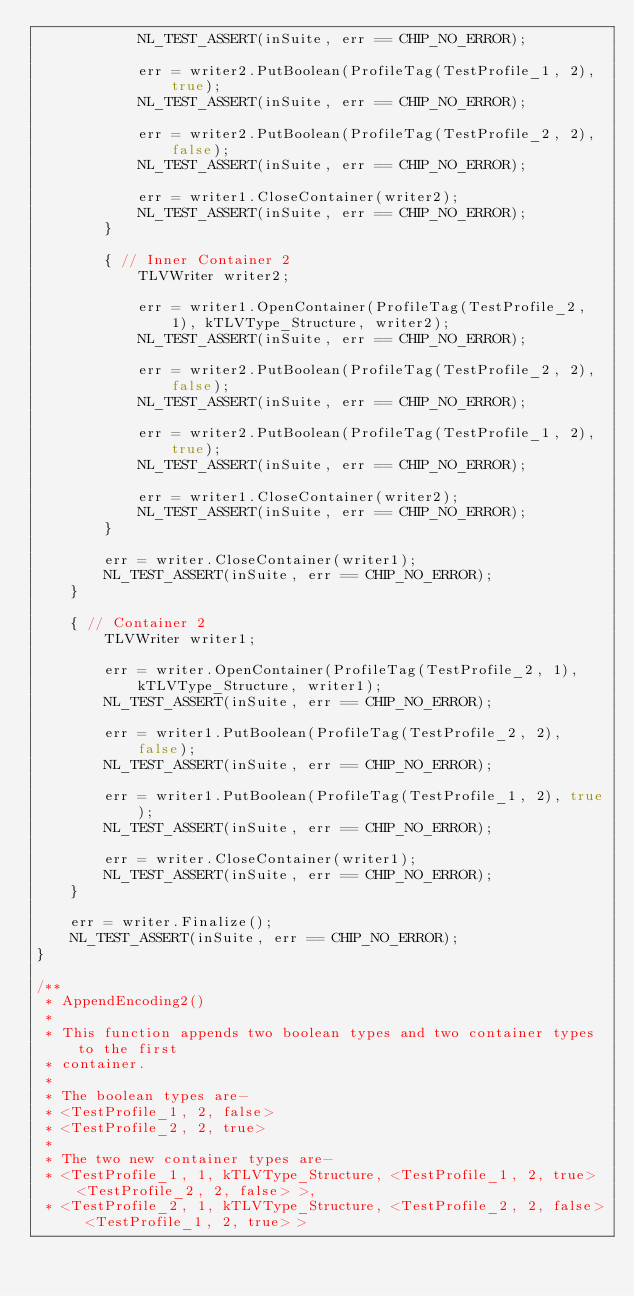Convert code to text. <code><loc_0><loc_0><loc_500><loc_500><_C++_>            NL_TEST_ASSERT(inSuite, err == CHIP_NO_ERROR);

            err = writer2.PutBoolean(ProfileTag(TestProfile_1, 2), true);
            NL_TEST_ASSERT(inSuite, err == CHIP_NO_ERROR);

            err = writer2.PutBoolean(ProfileTag(TestProfile_2, 2), false);
            NL_TEST_ASSERT(inSuite, err == CHIP_NO_ERROR);

            err = writer1.CloseContainer(writer2);
            NL_TEST_ASSERT(inSuite, err == CHIP_NO_ERROR);
        }

        { // Inner Container 2
            TLVWriter writer2;

            err = writer1.OpenContainer(ProfileTag(TestProfile_2, 1), kTLVType_Structure, writer2);
            NL_TEST_ASSERT(inSuite, err == CHIP_NO_ERROR);

            err = writer2.PutBoolean(ProfileTag(TestProfile_2, 2), false);
            NL_TEST_ASSERT(inSuite, err == CHIP_NO_ERROR);

            err = writer2.PutBoolean(ProfileTag(TestProfile_1, 2), true);
            NL_TEST_ASSERT(inSuite, err == CHIP_NO_ERROR);

            err = writer1.CloseContainer(writer2);
            NL_TEST_ASSERT(inSuite, err == CHIP_NO_ERROR);
        }

        err = writer.CloseContainer(writer1);
        NL_TEST_ASSERT(inSuite, err == CHIP_NO_ERROR);
    }

    { // Container 2
        TLVWriter writer1;

        err = writer.OpenContainer(ProfileTag(TestProfile_2, 1), kTLVType_Structure, writer1);
        NL_TEST_ASSERT(inSuite, err == CHIP_NO_ERROR);

        err = writer1.PutBoolean(ProfileTag(TestProfile_2, 2), false);
        NL_TEST_ASSERT(inSuite, err == CHIP_NO_ERROR);

        err = writer1.PutBoolean(ProfileTag(TestProfile_1, 2), true);
        NL_TEST_ASSERT(inSuite, err == CHIP_NO_ERROR);

        err = writer.CloseContainer(writer1);
        NL_TEST_ASSERT(inSuite, err == CHIP_NO_ERROR);
    }

    err = writer.Finalize();
    NL_TEST_ASSERT(inSuite, err == CHIP_NO_ERROR);
}

/**
 * AppendEncoding2()
 *
 * This function appends two boolean types and two container types to the first
 * container.
 *
 * The boolean types are-
 * <TestProfile_1, 2, false>
 * <TestProfile_2, 2, true>
 *
 * The two new container types are-
 * <TestProfile_1, 1, kTLVType_Structure, <TestProfile_1, 2, true> <TestProfile_2, 2, false> >,
 * <TestProfile_2, 1, kTLVType_Structure, <TestProfile_2, 2, false> <TestProfile_1, 2, true> ></code> 